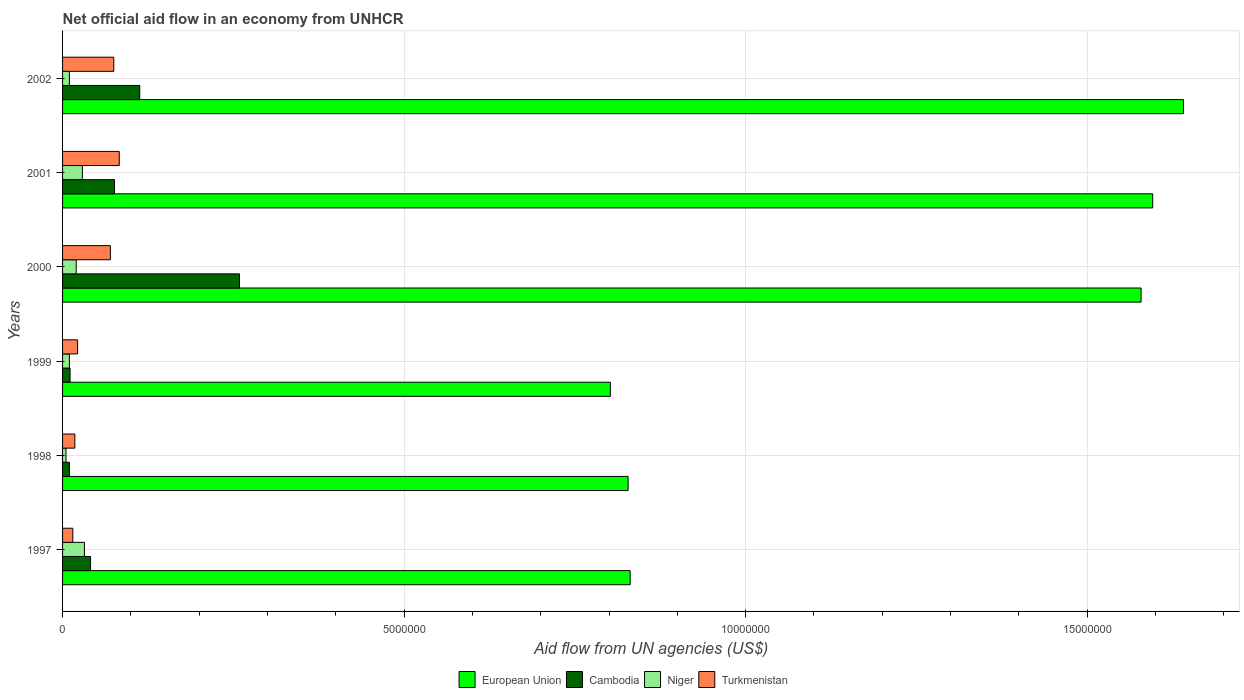How many different coloured bars are there?
Provide a succinct answer. 4. How many groups of bars are there?
Provide a short and direct response. 6. Are the number of bars on each tick of the Y-axis equal?
Your answer should be compact. Yes. How many bars are there on the 6th tick from the top?
Give a very brief answer. 4. What is the net official aid flow in Turkmenistan in 2001?
Ensure brevity in your answer.  8.30e+05. Across all years, what is the maximum net official aid flow in Niger?
Make the answer very short. 3.20e+05. Across all years, what is the minimum net official aid flow in Turkmenistan?
Your response must be concise. 1.50e+05. What is the total net official aid flow in Turkmenistan in the graph?
Give a very brief answer. 2.83e+06. What is the difference between the net official aid flow in Niger in 1998 and that in 2000?
Offer a terse response. -1.50e+05. What is the difference between the net official aid flow in European Union in 2001 and the net official aid flow in Cambodia in 2002?
Ensure brevity in your answer.  1.48e+07. What is the average net official aid flow in Cambodia per year?
Provide a short and direct response. 8.50e+05. In how many years, is the net official aid flow in Cambodia greater than 12000000 US$?
Your answer should be very brief. 0. What is the ratio of the net official aid flow in European Union in 1998 to that in 2001?
Keep it short and to the point. 0.52. Is the net official aid flow in Turkmenistan in 1998 less than that in 2001?
Offer a very short reply. Yes. Is the difference between the net official aid flow in Cambodia in 2000 and 2002 greater than the difference between the net official aid flow in Turkmenistan in 2000 and 2002?
Your response must be concise. Yes. What is the difference between the highest and the second highest net official aid flow in Niger?
Keep it short and to the point. 3.00e+04. What is the difference between the highest and the lowest net official aid flow in European Union?
Your answer should be very brief. 8.39e+06. In how many years, is the net official aid flow in Cambodia greater than the average net official aid flow in Cambodia taken over all years?
Your response must be concise. 2. Is it the case that in every year, the sum of the net official aid flow in Turkmenistan and net official aid flow in European Union is greater than the sum of net official aid flow in Niger and net official aid flow in Cambodia?
Your answer should be very brief. Yes. What does the 4th bar from the top in 1999 represents?
Ensure brevity in your answer.  European Union. What does the 2nd bar from the bottom in 1999 represents?
Your response must be concise. Cambodia. Is it the case that in every year, the sum of the net official aid flow in Turkmenistan and net official aid flow in Cambodia is greater than the net official aid flow in Niger?
Offer a terse response. Yes. How many bars are there?
Provide a succinct answer. 24. Are all the bars in the graph horizontal?
Ensure brevity in your answer.  Yes. What is the difference between two consecutive major ticks on the X-axis?
Keep it short and to the point. 5.00e+06. Does the graph contain any zero values?
Offer a terse response. No. How many legend labels are there?
Keep it short and to the point. 4. How are the legend labels stacked?
Your response must be concise. Horizontal. What is the title of the graph?
Your response must be concise. Net official aid flow in an economy from UNHCR. Does "Kyrgyz Republic" appear as one of the legend labels in the graph?
Your answer should be compact. No. What is the label or title of the X-axis?
Make the answer very short. Aid flow from UN agencies (US$). What is the Aid flow from UN agencies (US$) in European Union in 1997?
Give a very brief answer. 8.31e+06. What is the Aid flow from UN agencies (US$) in European Union in 1998?
Provide a short and direct response. 8.28e+06. What is the Aid flow from UN agencies (US$) in Cambodia in 1998?
Ensure brevity in your answer.  1.00e+05. What is the Aid flow from UN agencies (US$) of Niger in 1998?
Ensure brevity in your answer.  5.00e+04. What is the Aid flow from UN agencies (US$) in Turkmenistan in 1998?
Provide a succinct answer. 1.80e+05. What is the Aid flow from UN agencies (US$) of European Union in 1999?
Provide a succinct answer. 8.02e+06. What is the Aid flow from UN agencies (US$) in Cambodia in 1999?
Provide a succinct answer. 1.10e+05. What is the Aid flow from UN agencies (US$) of Turkmenistan in 1999?
Make the answer very short. 2.20e+05. What is the Aid flow from UN agencies (US$) of European Union in 2000?
Ensure brevity in your answer.  1.58e+07. What is the Aid flow from UN agencies (US$) of Cambodia in 2000?
Provide a short and direct response. 2.59e+06. What is the Aid flow from UN agencies (US$) in European Union in 2001?
Your answer should be very brief. 1.60e+07. What is the Aid flow from UN agencies (US$) in Cambodia in 2001?
Your response must be concise. 7.60e+05. What is the Aid flow from UN agencies (US$) of Niger in 2001?
Your response must be concise. 2.90e+05. What is the Aid flow from UN agencies (US$) of Turkmenistan in 2001?
Provide a succinct answer. 8.30e+05. What is the Aid flow from UN agencies (US$) in European Union in 2002?
Provide a short and direct response. 1.64e+07. What is the Aid flow from UN agencies (US$) in Cambodia in 2002?
Your response must be concise. 1.13e+06. What is the Aid flow from UN agencies (US$) of Turkmenistan in 2002?
Your answer should be very brief. 7.50e+05. Across all years, what is the maximum Aid flow from UN agencies (US$) in European Union?
Give a very brief answer. 1.64e+07. Across all years, what is the maximum Aid flow from UN agencies (US$) of Cambodia?
Your answer should be compact. 2.59e+06. Across all years, what is the maximum Aid flow from UN agencies (US$) of Turkmenistan?
Keep it short and to the point. 8.30e+05. Across all years, what is the minimum Aid flow from UN agencies (US$) of European Union?
Your answer should be compact. 8.02e+06. Across all years, what is the minimum Aid flow from UN agencies (US$) in Niger?
Your answer should be compact. 5.00e+04. What is the total Aid flow from UN agencies (US$) in European Union in the graph?
Offer a terse response. 7.28e+07. What is the total Aid flow from UN agencies (US$) of Cambodia in the graph?
Provide a short and direct response. 5.10e+06. What is the total Aid flow from UN agencies (US$) in Niger in the graph?
Your response must be concise. 1.06e+06. What is the total Aid flow from UN agencies (US$) in Turkmenistan in the graph?
Provide a short and direct response. 2.83e+06. What is the difference between the Aid flow from UN agencies (US$) in Niger in 1997 and that in 1998?
Provide a succinct answer. 2.70e+05. What is the difference between the Aid flow from UN agencies (US$) of Turkmenistan in 1997 and that in 1998?
Your answer should be very brief. -3.00e+04. What is the difference between the Aid flow from UN agencies (US$) of European Union in 1997 and that in 1999?
Provide a short and direct response. 2.90e+05. What is the difference between the Aid flow from UN agencies (US$) of European Union in 1997 and that in 2000?
Keep it short and to the point. -7.48e+06. What is the difference between the Aid flow from UN agencies (US$) in Cambodia in 1997 and that in 2000?
Ensure brevity in your answer.  -2.18e+06. What is the difference between the Aid flow from UN agencies (US$) of Turkmenistan in 1997 and that in 2000?
Keep it short and to the point. -5.50e+05. What is the difference between the Aid flow from UN agencies (US$) of European Union in 1997 and that in 2001?
Your response must be concise. -7.65e+06. What is the difference between the Aid flow from UN agencies (US$) of Cambodia in 1997 and that in 2001?
Keep it short and to the point. -3.50e+05. What is the difference between the Aid flow from UN agencies (US$) of Niger in 1997 and that in 2001?
Offer a very short reply. 3.00e+04. What is the difference between the Aid flow from UN agencies (US$) in Turkmenistan in 1997 and that in 2001?
Provide a succinct answer. -6.80e+05. What is the difference between the Aid flow from UN agencies (US$) in European Union in 1997 and that in 2002?
Keep it short and to the point. -8.10e+06. What is the difference between the Aid flow from UN agencies (US$) of Cambodia in 1997 and that in 2002?
Give a very brief answer. -7.20e+05. What is the difference between the Aid flow from UN agencies (US$) of Niger in 1997 and that in 2002?
Offer a very short reply. 2.20e+05. What is the difference between the Aid flow from UN agencies (US$) in Turkmenistan in 1997 and that in 2002?
Give a very brief answer. -6.00e+05. What is the difference between the Aid flow from UN agencies (US$) in European Union in 1998 and that in 1999?
Offer a terse response. 2.60e+05. What is the difference between the Aid flow from UN agencies (US$) in Cambodia in 1998 and that in 1999?
Offer a very short reply. -10000. What is the difference between the Aid flow from UN agencies (US$) of European Union in 1998 and that in 2000?
Your answer should be compact. -7.51e+06. What is the difference between the Aid flow from UN agencies (US$) of Cambodia in 1998 and that in 2000?
Offer a very short reply. -2.49e+06. What is the difference between the Aid flow from UN agencies (US$) in Niger in 1998 and that in 2000?
Your response must be concise. -1.50e+05. What is the difference between the Aid flow from UN agencies (US$) in Turkmenistan in 1998 and that in 2000?
Keep it short and to the point. -5.20e+05. What is the difference between the Aid flow from UN agencies (US$) of European Union in 1998 and that in 2001?
Your response must be concise. -7.68e+06. What is the difference between the Aid flow from UN agencies (US$) of Cambodia in 1998 and that in 2001?
Give a very brief answer. -6.60e+05. What is the difference between the Aid flow from UN agencies (US$) in Niger in 1998 and that in 2001?
Your response must be concise. -2.40e+05. What is the difference between the Aid flow from UN agencies (US$) of Turkmenistan in 1998 and that in 2001?
Your response must be concise. -6.50e+05. What is the difference between the Aid flow from UN agencies (US$) in European Union in 1998 and that in 2002?
Your response must be concise. -8.13e+06. What is the difference between the Aid flow from UN agencies (US$) of Cambodia in 1998 and that in 2002?
Provide a short and direct response. -1.03e+06. What is the difference between the Aid flow from UN agencies (US$) in Niger in 1998 and that in 2002?
Provide a succinct answer. -5.00e+04. What is the difference between the Aid flow from UN agencies (US$) in Turkmenistan in 1998 and that in 2002?
Make the answer very short. -5.70e+05. What is the difference between the Aid flow from UN agencies (US$) in European Union in 1999 and that in 2000?
Provide a short and direct response. -7.77e+06. What is the difference between the Aid flow from UN agencies (US$) in Cambodia in 1999 and that in 2000?
Offer a terse response. -2.48e+06. What is the difference between the Aid flow from UN agencies (US$) of Niger in 1999 and that in 2000?
Provide a succinct answer. -1.00e+05. What is the difference between the Aid flow from UN agencies (US$) in Turkmenistan in 1999 and that in 2000?
Offer a terse response. -4.80e+05. What is the difference between the Aid flow from UN agencies (US$) in European Union in 1999 and that in 2001?
Provide a short and direct response. -7.94e+06. What is the difference between the Aid flow from UN agencies (US$) in Cambodia in 1999 and that in 2001?
Ensure brevity in your answer.  -6.50e+05. What is the difference between the Aid flow from UN agencies (US$) in Turkmenistan in 1999 and that in 2001?
Provide a short and direct response. -6.10e+05. What is the difference between the Aid flow from UN agencies (US$) in European Union in 1999 and that in 2002?
Provide a short and direct response. -8.39e+06. What is the difference between the Aid flow from UN agencies (US$) in Cambodia in 1999 and that in 2002?
Keep it short and to the point. -1.02e+06. What is the difference between the Aid flow from UN agencies (US$) in Niger in 1999 and that in 2002?
Offer a very short reply. 0. What is the difference between the Aid flow from UN agencies (US$) of Turkmenistan in 1999 and that in 2002?
Provide a short and direct response. -5.30e+05. What is the difference between the Aid flow from UN agencies (US$) of European Union in 2000 and that in 2001?
Give a very brief answer. -1.70e+05. What is the difference between the Aid flow from UN agencies (US$) of Cambodia in 2000 and that in 2001?
Your response must be concise. 1.83e+06. What is the difference between the Aid flow from UN agencies (US$) in Niger in 2000 and that in 2001?
Ensure brevity in your answer.  -9.00e+04. What is the difference between the Aid flow from UN agencies (US$) in European Union in 2000 and that in 2002?
Your answer should be compact. -6.20e+05. What is the difference between the Aid flow from UN agencies (US$) of Cambodia in 2000 and that in 2002?
Provide a short and direct response. 1.46e+06. What is the difference between the Aid flow from UN agencies (US$) of European Union in 2001 and that in 2002?
Provide a short and direct response. -4.50e+05. What is the difference between the Aid flow from UN agencies (US$) in Cambodia in 2001 and that in 2002?
Provide a short and direct response. -3.70e+05. What is the difference between the Aid flow from UN agencies (US$) of Niger in 2001 and that in 2002?
Offer a terse response. 1.90e+05. What is the difference between the Aid flow from UN agencies (US$) of European Union in 1997 and the Aid flow from UN agencies (US$) of Cambodia in 1998?
Your answer should be compact. 8.21e+06. What is the difference between the Aid flow from UN agencies (US$) of European Union in 1997 and the Aid flow from UN agencies (US$) of Niger in 1998?
Keep it short and to the point. 8.26e+06. What is the difference between the Aid flow from UN agencies (US$) of European Union in 1997 and the Aid flow from UN agencies (US$) of Turkmenistan in 1998?
Ensure brevity in your answer.  8.13e+06. What is the difference between the Aid flow from UN agencies (US$) of Cambodia in 1997 and the Aid flow from UN agencies (US$) of Niger in 1998?
Offer a very short reply. 3.60e+05. What is the difference between the Aid flow from UN agencies (US$) of Cambodia in 1997 and the Aid flow from UN agencies (US$) of Turkmenistan in 1998?
Keep it short and to the point. 2.30e+05. What is the difference between the Aid flow from UN agencies (US$) of European Union in 1997 and the Aid flow from UN agencies (US$) of Cambodia in 1999?
Make the answer very short. 8.20e+06. What is the difference between the Aid flow from UN agencies (US$) of European Union in 1997 and the Aid flow from UN agencies (US$) of Niger in 1999?
Give a very brief answer. 8.21e+06. What is the difference between the Aid flow from UN agencies (US$) of European Union in 1997 and the Aid flow from UN agencies (US$) of Turkmenistan in 1999?
Offer a terse response. 8.09e+06. What is the difference between the Aid flow from UN agencies (US$) in European Union in 1997 and the Aid flow from UN agencies (US$) in Cambodia in 2000?
Your answer should be very brief. 5.72e+06. What is the difference between the Aid flow from UN agencies (US$) in European Union in 1997 and the Aid flow from UN agencies (US$) in Niger in 2000?
Your answer should be compact. 8.11e+06. What is the difference between the Aid flow from UN agencies (US$) in European Union in 1997 and the Aid flow from UN agencies (US$) in Turkmenistan in 2000?
Keep it short and to the point. 7.61e+06. What is the difference between the Aid flow from UN agencies (US$) of Niger in 1997 and the Aid flow from UN agencies (US$) of Turkmenistan in 2000?
Your answer should be very brief. -3.80e+05. What is the difference between the Aid flow from UN agencies (US$) in European Union in 1997 and the Aid flow from UN agencies (US$) in Cambodia in 2001?
Provide a short and direct response. 7.55e+06. What is the difference between the Aid flow from UN agencies (US$) in European Union in 1997 and the Aid flow from UN agencies (US$) in Niger in 2001?
Provide a short and direct response. 8.02e+06. What is the difference between the Aid flow from UN agencies (US$) of European Union in 1997 and the Aid flow from UN agencies (US$) of Turkmenistan in 2001?
Ensure brevity in your answer.  7.48e+06. What is the difference between the Aid flow from UN agencies (US$) of Cambodia in 1997 and the Aid flow from UN agencies (US$) of Niger in 2001?
Your response must be concise. 1.20e+05. What is the difference between the Aid flow from UN agencies (US$) in Cambodia in 1997 and the Aid flow from UN agencies (US$) in Turkmenistan in 2001?
Keep it short and to the point. -4.20e+05. What is the difference between the Aid flow from UN agencies (US$) in Niger in 1997 and the Aid flow from UN agencies (US$) in Turkmenistan in 2001?
Keep it short and to the point. -5.10e+05. What is the difference between the Aid flow from UN agencies (US$) of European Union in 1997 and the Aid flow from UN agencies (US$) of Cambodia in 2002?
Ensure brevity in your answer.  7.18e+06. What is the difference between the Aid flow from UN agencies (US$) in European Union in 1997 and the Aid flow from UN agencies (US$) in Niger in 2002?
Keep it short and to the point. 8.21e+06. What is the difference between the Aid flow from UN agencies (US$) of European Union in 1997 and the Aid flow from UN agencies (US$) of Turkmenistan in 2002?
Offer a terse response. 7.56e+06. What is the difference between the Aid flow from UN agencies (US$) of Cambodia in 1997 and the Aid flow from UN agencies (US$) of Niger in 2002?
Your answer should be very brief. 3.10e+05. What is the difference between the Aid flow from UN agencies (US$) of Niger in 1997 and the Aid flow from UN agencies (US$) of Turkmenistan in 2002?
Keep it short and to the point. -4.30e+05. What is the difference between the Aid flow from UN agencies (US$) of European Union in 1998 and the Aid flow from UN agencies (US$) of Cambodia in 1999?
Provide a succinct answer. 8.17e+06. What is the difference between the Aid flow from UN agencies (US$) in European Union in 1998 and the Aid flow from UN agencies (US$) in Niger in 1999?
Your answer should be very brief. 8.18e+06. What is the difference between the Aid flow from UN agencies (US$) in European Union in 1998 and the Aid flow from UN agencies (US$) in Turkmenistan in 1999?
Provide a succinct answer. 8.06e+06. What is the difference between the Aid flow from UN agencies (US$) of Cambodia in 1998 and the Aid flow from UN agencies (US$) of Niger in 1999?
Your answer should be compact. 0. What is the difference between the Aid flow from UN agencies (US$) in Niger in 1998 and the Aid flow from UN agencies (US$) in Turkmenistan in 1999?
Your answer should be compact. -1.70e+05. What is the difference between the Aid flow from UN agencies (US$) in European Union in 1998 and the Aid flow from UN agencies (US$) in Cambodia in 2000?
Provide a short and direct response. 5.69e+06. What is the difference between the Aid flow from UN agencies (US$) in European Union in 1998 and the Aid flow from UN agencies (US$) in Niger in 2000?
Provide a succinct answer. 8.08e+06. What is the difference between the Aid flow from UN agencies (US$) in European Union in 1998 and the Aid flow from UN agencies (US$) in Turkmenistan in 2000?
Your answer should be very brief. 7.58e+06. What is the difference between the Aid flow from UN agencies (US$) of Cambodia in 1998 and the Aid flow from UN agencies (US$) of Turkmenistan in 2000?
Keep it short and to the point. -6.00e+05. What is the difference between the Aid flow from UN agencies (US$) of Niger in 1998 and the Aid flow from UN agencies (US$) of Turkmenistan in 2000?
Give a very brief answer. -6.50e+05. What is the difference between the Aid flow from UN agencies (US$) in European Union in 1998 and the Aid flow from UN agencies (US$) in Cambodia in 2001?
Your response must be concise. 7.52e+06. What is the difference between the Aid flow from UN agencies (US$) of European Union in 1998 and the Aid flow from UN agencies (US$) of Niger in 2001?
Offer a very short reply. 7.99e+06. What is the difference between the Aid flow from UN agencies (US$) in European Union in 1998 and the Aid flow from UN agencies (US$) in Turkmenistan in 2001?
Ensure brevity in your answer.  7.45e+06. What is the difference between the Aid flow from UN agencies (US$) in Cambodia in 1998 and the Aid flow from UN agencies (US$) in Niger in 2001?
Provide a succinct answer. -1.90e+05. What is the difference between the Aid flow from UN agencies (US$) in Cambodia in 1998 and the Aid flow from UN agencies (US$) in Turkmenistan in 2001?
Your answer should be very brief. -7.30e+05. What is the difference between the Aid flow from UN agencies (US$) in Niger in 1998 and the Aid flow from UN agencies (US$) in Turkmenistan in 2001?
Offer a terse response. -7.80e+05. What is the difference between the Aid flow from UN agencies (US$) in European Union in 1998 and the Aid flow from UN agencies (US$) in Cambodia in 2002?
Your answer should be very brief. 7.15e+06. What is the difference between the Aid flow from UN agencies (US$) in European Union in 1998 and the Aid flow from UN agencies (US$) in Niger in 2002?
Offer a very short reply. 8.18e+06. What is the difference between the Aid flow from UN agencies (US$) of European Union in 1998 and the Aid flow from UN agencies (US$) of Turkmenistan in 2002?
Provide a succinct answer. 7.53e+06. What is the difference between the Aid flow from UN agencies (US$) of Cambodia in 1998 and the Aid flow from UN agencies (US$) of Niger in 2002?
Offer a very short reply. 0. What is the difference between the Aid flow from UN agencies (US$) in Cambodia in 1998 and the Aid flow from UN agencies (US$) in Turkmenistan in 2002?
Provide a short and direct response. -6.50e+05. What is the difference between the Aid flow from UN agencies (US$) of Niger in 1998 and the Aid flow from UN agencies (US$) of Turkmenistan in 2002?
Offer a very short reply. -7.00e+05. What is the difference between the Aid flow from UN agencies (US$) in European Union in 1999 and the Aid flow from UN agencies (US$) in Cambodia in 2000?
Offer a terse response. 5.43e+06. What is the difference between the Aid flow from UN agencies (US$) of European Union in 1999 and the Aid flow from UN agencies (US$) of Niger in 2000?
Make the answer very short. 7.82e+06. What is the difference between the Aid flow from UN agencies (US$) of European Union in 1999 and the Aid flow from UN agencies (US$) of Turkmenistan in 2000?
Your response must be concise. 7.32e+06. What is the difference between the Aid flow from UN agencies (US$) of Cambodia in 1999 and the Aid flow from UN agencies (US$) of Turkmenistan in 2000?
Keep it short and to the point. -5.90e+05. What is the difference between the Aid flow from UN agencies (US$) of Niger in 1999 and the Aid flow from UN agencies (US$) of Turkmenistan in 2000?
Your answer should be very brief. -6.00e+05. What is the difference between the Aid flow from UN agencies (US$) in European Union in 1999 and the Aid flow from UN agencies (US$) in Cambodia in 2001?
Give a very brief answer. 7.26e+06. What is the difference between the Aid flow from UN agencies (US$) in European Union in 1999 and the Aid flow from UN agencies (US$) in Niger in 2001?
Provide a short and direct response. 7.73e+06. What is the difference between the Aid flow from UN agencies (US$) in European Union in 1999 and the Aid flow from UN agencies (US$) in Turkmenistan in 2001?
Make the answer very short. 7.19e+06. What is the difference between the Aid flow from UN agencies (US$) of Cambodia in 1999 and the Aid flow from UN agencies (US$) of Turkmenistan in 2001?
Make the answer very short. -7.20e+05. What is the difference between the Aid flow from UN agencies (US$) in Niger in 1999 and the Aid flow from UN agencies (US$) in Turkmenistan in 2001?
Your answer should be compact. -7.30e+05. What is the difference between the Aid flow from UN agencies (US$) of European Union in 1999 and the Aid flow from UN agencies (US$) of Cambodia in 2002?
Provide a succinct answer. 6.89e+06. What is the difference between the Aid flow from UN agencies (US$) of European Union in 1999 and the Aid flow from UN agencies (US$) of Niger in 2002?
Give a very brief answer. 7.92e+06. What is the difference between the Aid flow from UN agencies (US$) of European Union in 1999 and the Aid flow from UN agencies (US$) of Turkmenistan in 2002?
Your response must be concise. 7.27e+06. What is the difference between the Aid flow from UN agencies (US$) in Cambodia in 1999 and the Aid flow from UN agencies (US$) in Niger in 2002?
Offer a very short reply. 10000. What is the difference between the Aid flow from UN agencies (US$) of Cambodia in 1999 and the Aid flow from UN agencies (US$) of Turkmenistan in 2002?
Make the answer very short. -6.40e+05. What is the difference between the Aid flow from UN agencies (US$) in Niger in 1999 and the Aid flow from UN agencies (US$) in Turkmenistan in 2002?
Your answer should be very brief. -6.50e+05. What is the difference between the Aid flow from UN agencies (US$) in European Union in 2000 and the Aid flow from UN agencies (US$) in Cambodia in 2001?
Make the answer very short. 1.50e+07. What is the difference between the Aid flow from UN agencies (US$) of European Union in 2000 and the Aid flow from UN agencies (US$) of Niger in 2001?
Provide a short and direct response. 1.55e+07. What is the difference between the Aid flow from UN agencies (US$) in European Union in 2000 and the Aid flow from UN agencies (US$) in Turkmenistan in 2001?
Ensure brevity in your answer.  1.50e+07. What is the difference between the Aid flow from UN agencies (US$) in Cambodia in 2000 and the Aid flow from UN agencies (US$) in Niger in 2001?
Your answer should be compact. 2.30e+06. What is the difference between the Aid flow from UN agencies (US$) in Cambodia in 2000 and the Aid flow from UN agencies (US$) in Turkmenistan in 2001?
Ensure brevity in your answer.  1.76e+06. What is the difference between the Aid flow from UN agencies (US$) of Niger in 2000 and the Aid flow from UN agencies (US$) of Turkmenistan in 2001?
Keep it short and to the point. -6.30e+05. What is the difference between the Aid flow from UN agencies (US$) in European Union in 2000 and the Aid flow from UN agencies (US$) in Cambodia in 2002?
Your answer should be very brief. 1.47e+07. What is the difference between the Aid flow from UN agencies (US$) of European Union in 2000 and the Aid flow from UN agencies (US$) of Niger in 2002?
Provide a short and direct response. 1.57e+07. What is the difference between the Aid flow from UN agencies (US$) in European Union in 2000 and the Aid flow from UN agencies (US$) in Turkmenistan in 2002?
Offer a very short reply. 1.50e+07. What is the difference between the Aid flow from UN agencies (US$) of Cambodia in 2000 and the Aid flow from UN agencies (US$) of Niger in 2002?
Keep it short and to the point. 2.49e+06. What is the difference between the Aid flow from UN agencies (US$) of Cambodia in 2000 and the Aid flow from UN agencies (US$) of Turkmenistan in 2002?
Offer a very short reply. 1.84e+06. What is the difference between the Aid flow from UN agencies (US$) in Niger in 2000 and the Aid flow from UN agencies (US$) in Turkmenistan in 2002?
Provide a short and direct response. -5.50e+05. What is the difference between the Aid flow from UN agencies (US$) in European Union in 2001 and the Aid flow from UN agencies (US$) in Cambodia in 2002?
Give a very brief answer. 1.48e+07. What is the difference between the Aid flow from UN agencies (US$) in European Union in 2001 and the Aid flow from UN agencies (US$) in Niger in 2002?
Ensure brevity in your answer.  1.59e+07. What is the difference between the Aid flow from UN agencies (US$) of European Union in 2001 and the Aid flow from UN agencies (US$) of Turkmenistan in 2002?
Keep it short and to the point. 1.52e+07. What is the difference between the Aid flow from UN agencies (US$) in Niger in 2001 and the Aid flow from UN agencies (US$) in Turkmenistan in 2002?
Make the answer very short. -4.60e+05. What is the average Aid flow from UN agencies (US$) in European Union per year?
Your answer should be compact. 1.21e+07. What is the average Aid flow from UN agencies (US$) of Cambodia per year?
Your answer should be very brief. 8.50e+05. What is the average Aid flow from UN agencies (US$) in Niger per year?
Your answer should be compact. 1.77e+05. What is the average Aid flow from UN agencies (US$) of Turkmenistan per year?
Your answer should be compact. 4.72e+05. In the year 1997, what is the difference between the Aid flow from UN agencies (US$) in European Union and Aid flow from UN agencies (US$) in Cambodia?
Your response must be concise. 7.90e+06. In the year 1997, what is the difference between the Aid flow from UN agencies (US$) in European Union and Aid flow from UN agencies (US$) in Niger?
Provide a short and direct response. 7.99e+06. In the year 1997, what is the difference between the Aid flow from UN agencies (US$) of European Union and Aid flow from UN agencies (US$) of Turkmenistan?
Make the answer very short. 8.16e+06. In the year 1997, what is the difference between the Aid flow from UN agencies (US$) in Cambodia and Aid flow from UN agencies (US$) in Niger?
Your answer should be compact. 9.00e+04. In the year 1997, what is the difference between the Aid flow from UN agencies (US$) of Cambodia and Aid flow from UN agencies (US$) of Turkmenistan?
Provide a succinct answer. 2.60e+05. In the year 1998, what is the difference between the Aid flow from UN agencies (US$) of European Union and Aid flow from UN agencies (US$) of Cambodia?
Your response must be concise. 8.18e+06. In the year 1998, what is the difference between the Aid flow from UN agencies (US$) in European Union and Aid flow from UN agencies (US$) in Niger?
Provide a succinct answer. 8.23e+06. In the year 1998, what is the difference between the Aid flow from UN agencies (US$) of European Union and Aid flow from UN agencies (US$) of Turkmenistan?
Provide a succinct answer. 8.10e+06. In the year 1999, what is the difference between the Aid flow from UN agencies (US$) of European Union and Aid flow from UN agencies (US$) of Cambodia?
Ensure brevity in your answer.  7.91e+06. In the year 1999, what is the difference between the Aid flow from UN agencies (US$) in European Union and Aid flow from UN agencies (US$) in Niger?
Give a very brief answer. 7.92e+06. In the year 1999, what is the difference between the Aid flow from UN agencies (US$) of European Union and Aid flow from UN agencies (US$) of Turkmenistan?
Your answer should be very brief. 7.80e+06. In the year 1999, what is the difference between the Aid flow from UN agencies (US$) in Cambodia and Aid flow from UN agencies (US$) in Turkmenistan?
Ensure brevity in your answer.  -1.10e+05. In the year 1999, what is the difference between the Aid flow from UN agencies (US$) in Niger and Aid flow from UN agencies (US$) in Turkmenistan?
Your answer should be compact. -1.20e+05. In the year 2000, what is the difference between the Aid flow from UN agencies (US$) in European Union and Aid flow from UN agencies (US$) in Cambodia?
Provide a short and direct response. 1.32e+07. In the year 2000, what is the difference between the Aid flow from UN agencies (US$) of European Union and Aid flow from UN agencies (US$) of Niger?
Provide a succinct answer. 1.56e+07. In the year 2000, what is the difference between the Aid flow from UN agencies (US$) of European Union and Aid flow from UN agencies (US$) of Turkmenistan?
Offer a terse response. 1.51e+07. In the year 2000, what is the difference between the Aid flow from UN agencies (US$) of Cambodia and Aid flow from UN agencies (US$) of Niger?
Keep it short and to the point. 2.39e+06. In the year 2000, what is the difference between the Aid flow from UN agencies (US$) of Cambodia and Aid flow from UN agencies (US$) of Turkmenistan?
Offer a terse response. 1.89e+06. In the year 2000, what is the difference between the Aid flow from UN agencies (US$) in Niger and Aid flow from UN agencies (US$) in Turkmenistan?
Make the answer very short. -5.00e+05. In the year 2001, what is the difference between the Aid flow from UN agencies (US$) of European Union and Aid flow from UN agencies (US$) of Cambodia?
Provide a succinct answer. 1.52e+07. In the year 2001, what is the difference between the Aid flow from UN agencies (US$) of European Union and Aid flow from UN agencies (US$) of Niger?
Your response must be concise. 1.57e+07. In the year 2001, what is the difference between the Aid flow from UN agencies (US$) in European Union and Aid flow from UN agencies (US$) in Turkmenistan?
Your answer should be very brief. 1.51e+07. In the year 2001, what is the difference between the Aid flow from UN agencies (US$) in Niger and Aid flow from UN agencies (US$) in Turkmenistan?
Your answer should be compact. -5.40e+05. In the year 2002, what is the difference between the Aid flow from UN agencies (US$) of European Union and Aid flow from UN agencies (US$) of Cambodia?
Give a very brief answer. 1.53e+07. In the year 2002, what is the difference between the Aid flow from UN agencies (US$) of European Union and Aid flow from UN agencies (US$) of Niger?
Keep it short and to the point. 1.63e+07. In the year 2002, what is the difference between the Aid flow from UN agencies (US$) of European Union and Aid flow from UN agencies (US$) of Turkmenistan?
Make the answer very short. 1.57e+07. In the year 2002, what is the difference between the Aid flow from UN agencies (US$) in Cambodia and Aid flow from UN agencies (US$) in Niger?
Make the answer very short. 1.03e+06. In the year 2002, what is the difference between the Aid flow from UN agencies (US$) in Cambodia and Aid flow from UN agencies (US$) in Turkmenistan?
Ensure brevity in your answer.  3.80e+05. In the year 2002, what is the difference between the Aid flow from UN agencies (US$) in Niger and Aid flow from UN agencies (US$) in Turkmenistan?
Provide a short and direct response. -6.50e+05. What is the ratio of the Aid flow from UN agencies (US$) of Turkmenistan in 1997 to that in 1998?
Offer a terse response. 0.83. What is the ratio of the Aid flow from UN agencies (US$) of European Union in 1997 to that in 1999?
Provide a succinct answer. 1.04. What is the ratio of the Aid flow from UN agencies (US$) of Cambodia in 1997 to that in 1999?
Your answer should be compact. 3.73. What is the ratio of the Aid flow from UN agencies (US$) in Turkmenistan in 1997 to that in 1999?
Make the answer very short. 0.68. What is the ratio of the Aid flow from UN agencies (US$) of European Union in 1997 to that in 2000?
Make the answer very short. 0.53. What is the ratio of the Aid flow from UN agencies (US$) of Cambodia in 1997 to that in 2000?
Your answer should be compact. 0.16. What is the ratio of the Aid flow from UN agencies (US$) in Turkmenistan in 1997 to that in 2000?
Keep it short and to the point. 0.21. What is the ratio of the Aid flow from UN agencies (US$) in European Union in 1997 to that in 2001?
Give a very brief answer. 0.52. What is the ratio of the Aid flow from UN agencies (US$) in Cambodia in 1997 to that in 2001?
Offer a terse response. 0.54. What is the ratio of the Aid flow from UN agencies (US$) in Niger in 1997 to that in 2001?
Give a very brief answer. 1.1. What is the ratio of the Aid flow from UN agencies (US$) in Turkmenistan in 1997 to that in 2001?
Your answer should be very brief. 0.18. What is the ratio of the Aid flow from UN agencies (US$) in European Union in 1997 to that in 2002?
Your response must be concise. 0.51. What is the ratio of the Aid flow from UN agencies (US$) of Cambodia in 1997 to that in 2002?
Make the answer very short. 0.36. What is the ratio of the Aid flow from UN agencies (US$) in European Union in 1998 to that in 1999?
Your answer should be very brief. 1.03. What is the ratio of the Aid flow from UN agencies (US$) in Turkmenistan in 1998 to that in 1999?
Your response must be concise. 0.82. What is the ratio of the Aid flow from UN agencies (US$) of European Union in 1998 to that in 2000?
Provide a succinct answer. 0.52. What is the ratio of the Aid flow from UN agencies (US$) in Cambodia in 1998 to that in 2000?
Give a very brief answer. 0.04. What is the ratio of the Aid flow from UN agencies (US$) in Niger in 1998 to that in 2000?
Provide a short and direct response. 0.25. What is the ratio of the Aid flow from UN agencies (US$) in Turkmenistan in 1998 to that in 2000?
Your response must be concise. 0.26. What is the ratio of the Aid flow from UN agencies (US$) in European Union in 1998 to that in 2001?
Make the answer very short. 0.52. What is the ratio of the Aid flow from UN agencies (US$) of Cambodia in 1998 to that in 2001?
Provide a succinct answer. 0.13. What is the ratio of the Aid flow from UN agencies (US$) in Niger in 1998 to that in 2001?
Give a very brief answer. 0.17. What is the ratio of the Aid flow from UN agencies (US$) in Turkmenistan in 1998 to that in 2001?
Your answer should be very brief. 0.22. What is the ratio of the Aid flow from UN agencies (US$) in European Union in 1998 to that in 2002?
Give a very brief answer. 0.5. What is the ratio of the Aid flow from UN agencies (US$) in Cambodia in 1998 to that in 2002?
Provide a short and direct response. 0.09. What is the ratio of the Aid flow from UN agencies (US$) in Turkmenistan in 1998 to that in 2002?
Provide a succinct answer. 0.24. What is the ratio of the Aid flow from UN agencies (US$) of European Union in 1999 to that in 2000?
Your response must be concise. 0.51. What is the ratio of the Aid flow from UN agencies (US$) in Cambodia in 1999 to that in 2000?
Provide a succinct answer. 0.04. What is the ratio of the Aid flow from UN agencies (US$) of Turkmenistan in 1999 to that in 2000?
Your answer should be very brief. 0.31. What is the ratio of the Aid flow from UN agencies (US$) of European Union in 1999 to that in 2001?
Make the answer very short. 0.5. What is the ratio of the Aid flow from UN agencies (US$) in Cambodia in 1999 to that in 2001?
Offer a terse response. 0.14. What is the ratio of the Aid flow from UN agencies (US$) of Niger in 1999 to that in 2001?
Provide a succinct answer. 0.34. What is the ratio of the Aid flow from UN agencies (US$) in Turkmenistan in 1999 to that in 2001?
Make the answer very short. 0.27. What is the ratio of the Aid flow from UN agencies (US$) in European Union in 1999 to that in 2002?
Keep it short and to the point. 0.49. What is the ratio of the Aid flow from UN agencies (US$) in Cambodia in 1999 to that in 2002?
Offer a very short reply. 0.1. What is the ratio of the Aid flow from UN agencies (US$) of Niger in 1999 to that in 2002?
Offer a very short reply. 1. What is the ratio of the Aid flow from UN agencies (US$) of Turkmenistan in 1999 to that in 2002?
Your answer should be compact. 0.29. What is the ratio of the Aid flow from UN agencies (US$) in European Union in 2000 to that in 2001?
Your answer should be compact. 0.99. What is the ratio of the Aid flow from UN agencies (US$) of Cambodia in 2000 to that in 2001?
Provide a succinct answer. 3.41. What is the ratio of the Aid flow from UN agencies (US$) of Niger in 2000 to that in 2001?
Offer a very short reply. 0.69. What is the ratio of the Aid flow from UN agencies (US$) in Turkmenistan in 2000 to that in 2001?
Keep it short and to the point. 0.84. What is the ratio of the Aid flow from UN agencies (US$) of European Union in 2000 to that in 2002?
Offer a terse response. 0.96. What is the ratio of the Aid flow from UN agencies (US$) of Cambodia in 2000 to that in 2002?
Your response must be concise. 2.29. What is the ratio of the Aid flow from UN agencies (US$) in European Union in 2001 to that in 2002?
Give a very brief answer. 0.97. What is the ratio of the Aid flow from UN agencies (US$) in Cambodia in 2001 to that in 2002?
Provide a succinct answer. 0.67. What is the ratio of the Aid flow from UN agencies (US$) in Turkmenistan in 2001 to that in 2002?
Make the answer very short. 1.11. What is the difference between the highest and the second highest Aid flow from UN agencies (US$) in Cambodia?
Keep it short and to the point. 1.46e+06. What is the difference between the highest and the second highest Aid flow from UN agencies (US$) in Turkmenistan?
Your answer should be compact. 8.00e+04. What is the difference between the highest and the lowest Aid flow from UN agencies (US$) of European Union?
Your response must be concise. 8.39e+06. What is the difference between the highest and the lowest Aid flow from UN agencies (US$) of Cambodia?
Offer a terse response. 2.49e+06. What is the difference between the highest and the lowest Aid flow from UN agencies (US$) of Niger?
Your answer should be very brief. 2.70e+05. What is the difference between the highest and the lowest Aid flow from UN agencies (US$) of Turkmenistan?
Ensure brevity in your answer.  6.80e+05. 